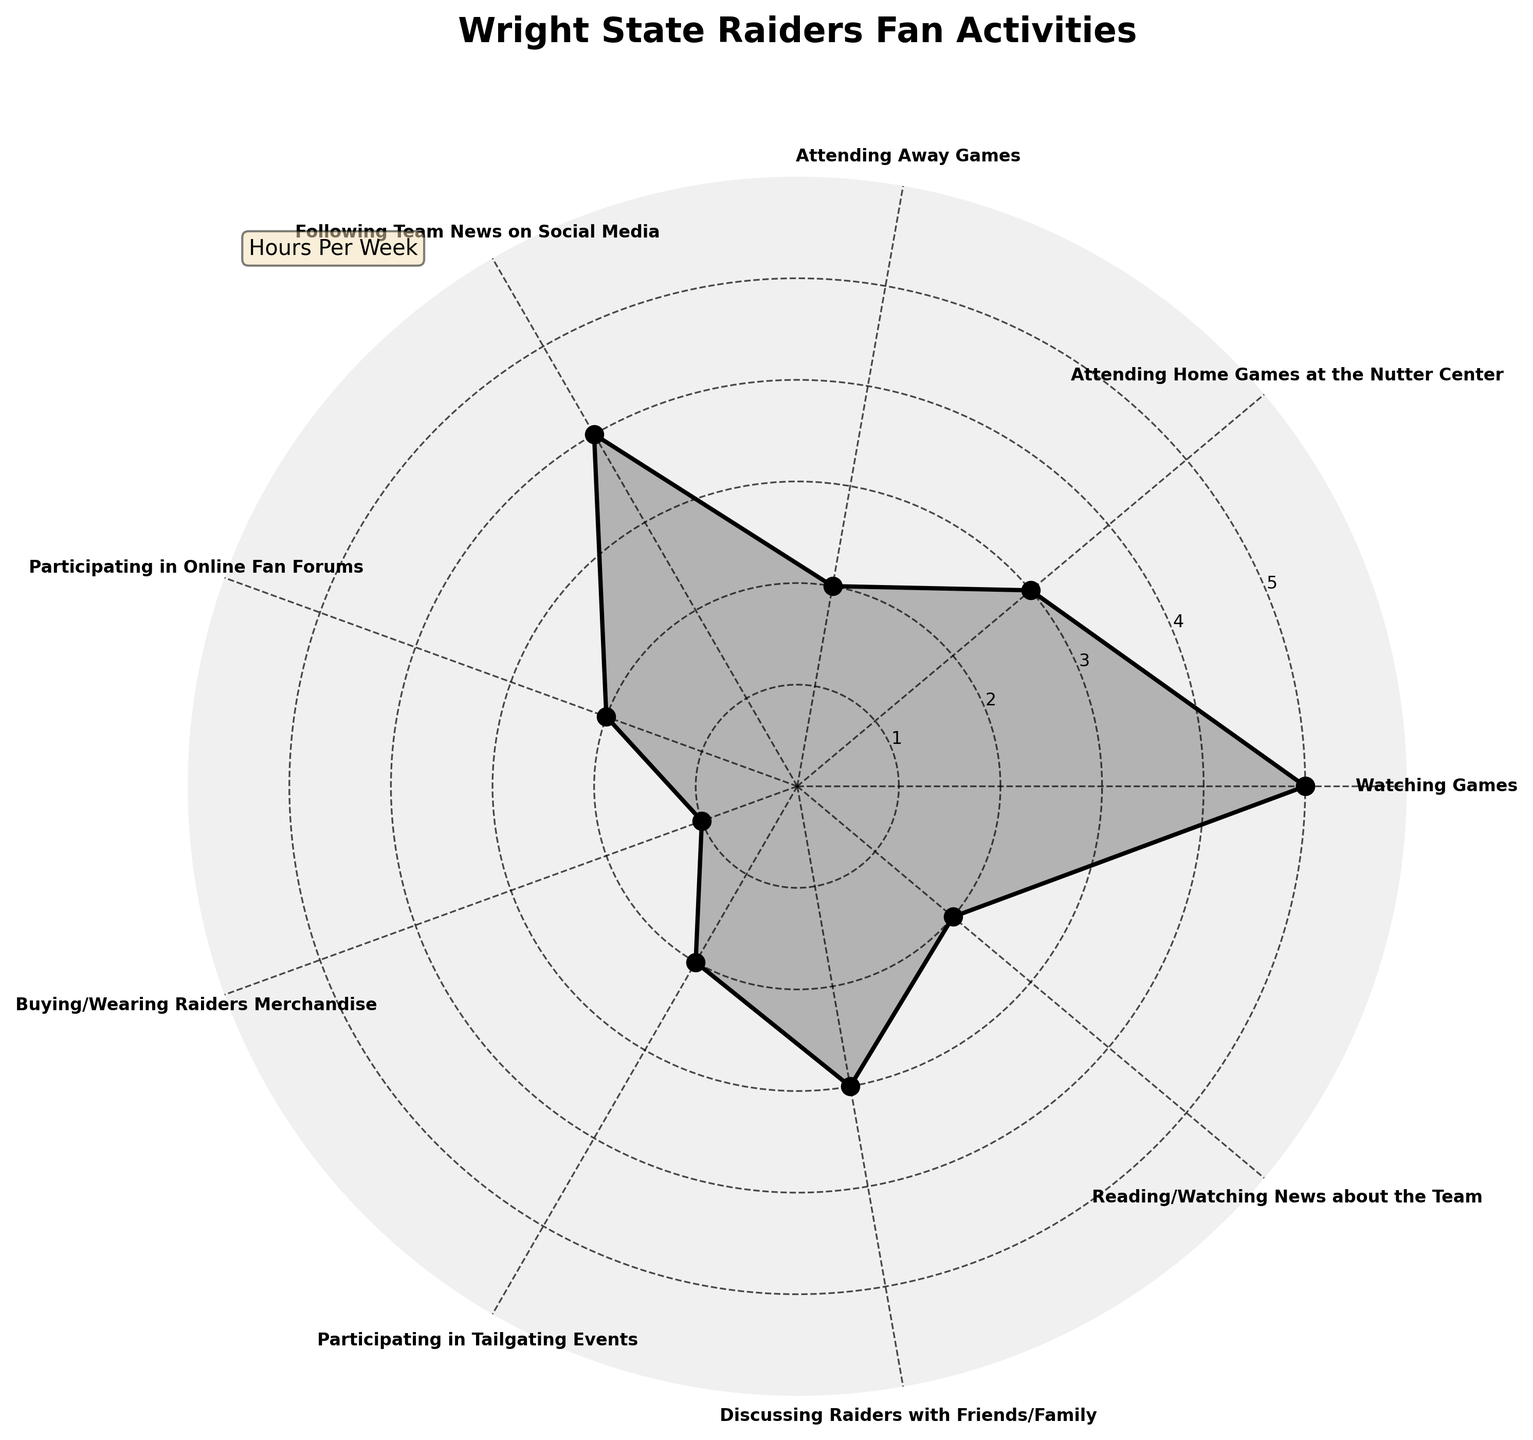What's the title of the polar area chart? The title is usually at the top of the chart. It provides an overview of what the chart is about.
Answer: Wright State Raiders Fan Activities How many different types of activities are shown in the chart? Count each unique label on the angular ticks of the chart.
Answer: 9 Which activity do fans spend the most hours on? Look for the longest sector in the polar area chart, as it indicates the maximum hours spent.
Answer: Watching Games How do the hours spent watching games compare to the hours spent following team news on social media? Compare the length of the sectors for "Watching Games" and "Following Team News on Social Media." Watching Games has 5 hours, and Following Team News on Social Media has 4 hours.
Answer: 1 hour more What is the total time spent on activities involving attending games (home and away)? Sum the hours spent on "Attending Home Games at the Nutter Center" and "Attending Away Games."
Answer: 5 hours What is the average time spent on all activities? Sum the hours of all activities and divide by the number of activities. (5+3+2+4+2+1+2+3+2)/9 = 2.7
Answer: 2.7 hours Which activity has the same amount of hours as participating in online fan forums? Locate the activity with a sector of the same length as "Participating in Online Fan Forums," which is 2 hours.
Answer: Attending Away Games, Participating in Tailgating Events, Reading/Watching News about the Team Which activities have less than 3 hours dedicated to them? Identify all activities with sectors shorter than the 3-hour mark on the radial axis.
Answer: Attending Away Games, Participating in Online Fan Forums, Buying/Wearing Raiders Merchandise, Participating in Tailgating Events, Reading/Watching News about the Team How does the time spent discussing the Raiders with friends/family compare to the time spent buying/wearing Raiders merchandise? Compare the length of the sectors for "Discussing Raiders with Friends/Family" (3 hours) and "Buying/Wearing Raiders Merchandise" (1 hour).
Answer: 2 hours more What is the total time spent on activities related to social media? Sum the hours of activities related to social media: "Following Team News on Social Media" (4 hours) and "Participating in Online Fan Forums" (2 hours).
Answer: 6 hours 